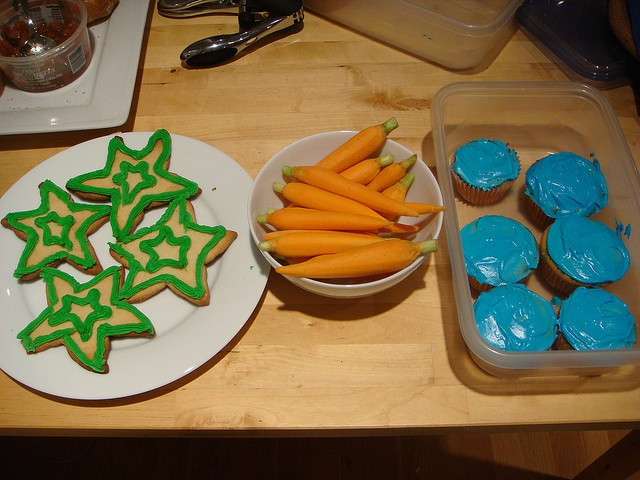Describe the objects in this image and their specific colors. I can see dining table in maroon, tan, and olive tones, bowl in maroon, orange, red, and tan tones, cake in maroon and teal tones, bowl in maroon, brown, olive, and gray tones, and bowl in maroon, black, and gray tones in this image. 